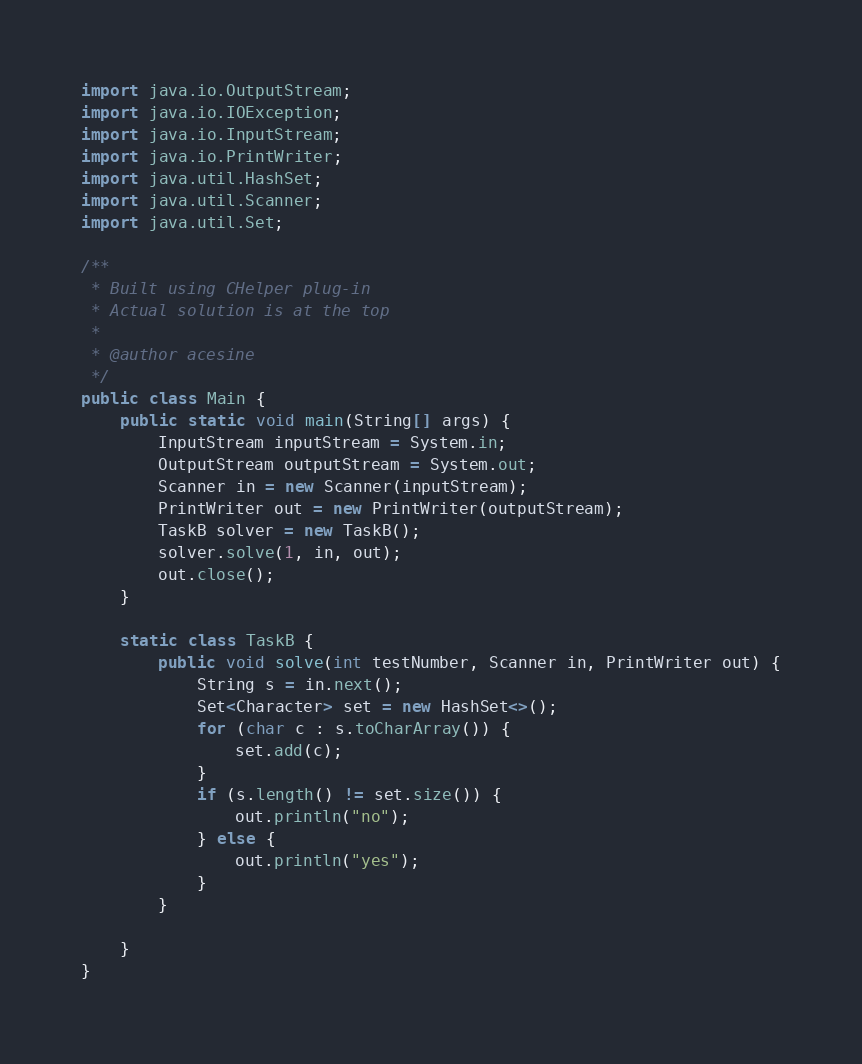Convert code to text. <code><loc_0><loc_0><loc_500><loc_500><_Java_>import java.io.OutputStream;
import java.io.IOException;
import java.io.InputStream;
import java.io.PrintWriter;
import java.util.HashSet;
import java.util.Scanner;
import java.util.Set;

/**
 * Built using CHelper plug-in
 * Actual solution is at the top
 *
 * @author acesine
 */
public class Main {
    public static void main(String[] args) {
        InputStream inputStream = System.in;
        OutputStream outputStream = System.out;
        Scanner in = new Scanner(inputStream);
        PrintWriter out = new PrintWriter(outputStream);
        TaskB solver = new TaskB();
        solver.solve(1, in, out);
        out.close();
    }

    static class TaskB {
        public void solve(int testNumber, Scanner in, PrintWriter out) {
            String s = in.next();
            Set<Character> set = new HashSet<>();
            for (char c : s.toCharArray()) {
                set.add(c);
            }
            if (s.length() != set.size()) {
                out.println("no");
            } else {
                out.println("yes");
            }
        }

    }
}

</code> 